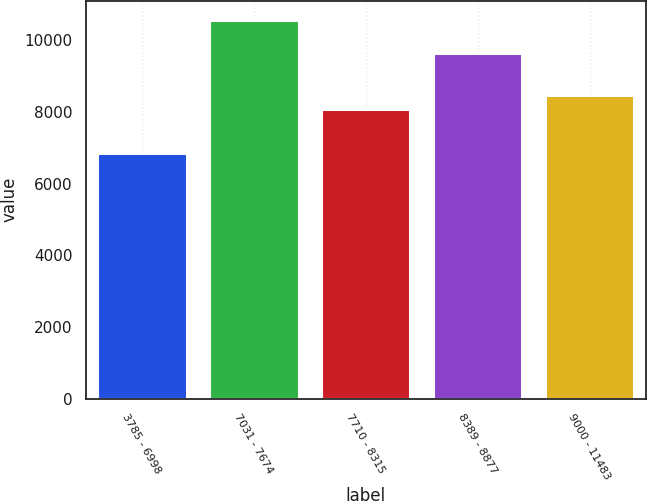Convert chart to OTSL. <chart><loc_0><loc_0><loc_500><loc_500><bar_chart><fcel>3785 - 6998<fcel>7031 - 7674<fcel>7710 - 8315<fcel>8389 - 8877<fcel>9000 - 11483<nl><fcel>6859<fcel>10579<fcel>8095<fcel>9644<fcel>8467<nl></chart> 